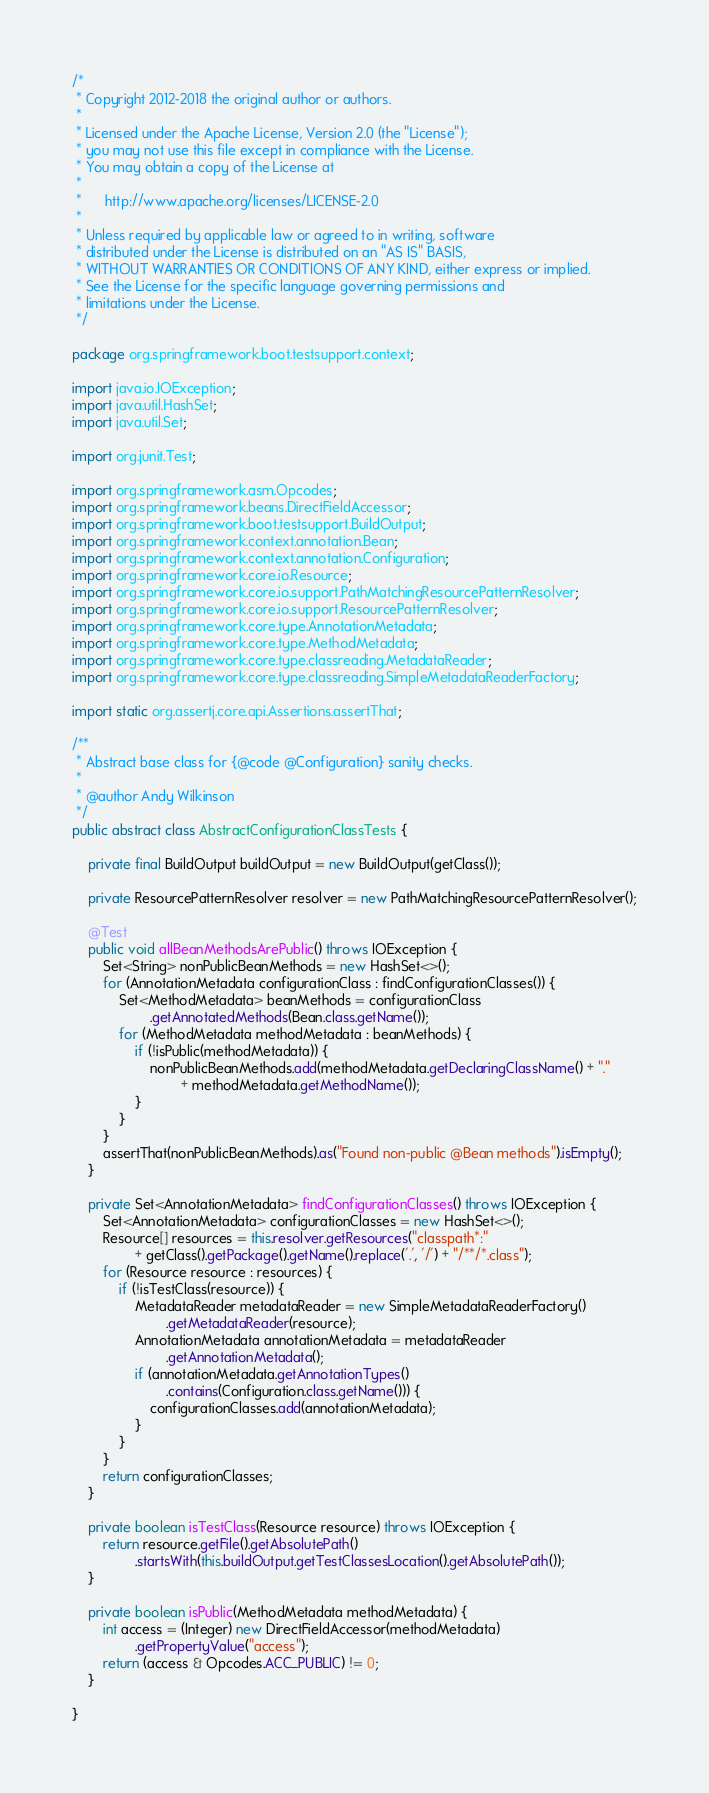Convert code to text. <code><loc_0><loc_0><loc_500><loc_500><_Java_>/*
 * Copyright 2012-2018 the original author or authors.
 *
 * Licensed under the Apache License, Version 2.0 (the "License");
 * you may not use this file except in compliance with the License.
 * You may obtain a copy of the License at
 *
 *      http://www.apache.org/licenses/LICENSE-2.0
 *
 * Unless required by applicable law or agreed to in writing, software
 * distributed under the License is distributed on an "AS IS" BASIS,
 * WITHOUT WARRANTIES OR CONDITIONS OF ANY KIND, either express or implied.
 * See the License for the specific language governing permissions and
 * limitations under the License.
 */

package org.springframework.boot.testsupport.context;

import java.io.IOException;
import java.util.HashSet;
import java.util.Set;

import org.junit.Test;

import org.springframework.asm.Opcodes;
import org.springframework.beans.DirectFieldAccessor;
import org.springframework.boot.testsupport.BuildOutput;
import org.springframework.context.annotation.Bean;
import org.springframework.context.annotation.Configuration;
import org.springframework.core.io.Resource;
import org.springframework.core.io.support.PathMatchingResourcePatternResolver;
import org.springframework.core.io.support.ResourcePatternResolver;
import org.springframework.core.type.AnnotationMetadata;
import org.springframework.core.type.MethodMetadata;
import org.springframework.core.type.classreading.MetadataReader;
import org.springframework.core.type.classreading.SimpleMetadataReaderFactory;

import static org.assertj.core.api.Assertions.assertThat;

/**
 * Abstract base class for {@code @Configuration} sanity checks.
 *
 * @author Andy Wilkinson
 */
public abstract class AbstractConfigurationClassTests {

	private final BuildOutput buildOutput = new BuildOutput(getClass());

	private ResourcePatternResolver resolver = new PathMatchingResourcePatternResolver();

	@Test
	public void allBeanMethodsArePublic() throws IOException {
		Set<String> nonPublicBeanMethods = new HashSet<>();
		for (AnnotationMetadata configurationClass : findConfigurationClasses()) {
			Set<MethodMetadata> beanMethods = configurationClass
					.getAnnotatedMethods(Bean.class.getName());
			for (MethodMetadata methodMetadata : beanMethods) {
				if (!isPublic(methodMetadata)) {
					nonPublicBeanMethods.add(methodMetadata.getDeclaringClassName() + "."
							+ methodMetadata.getMethodName());
				}
			}
		}
		assertThat(nonPublicBeanMethods).as("Found non-public @Bean methods").isEmpty();
	}

	private Set<AnnotationMetadata> findConfigurationClasses() throws IOException {
		Set<AnnotationMetadata> configurationClasses = new HashSet<>();
		Resource[] resources = this.resolver.getResources("classpath*:"
				+ getClass().getPackage().getName().replace('.', '/') + "/**/*.class");
		for (Resource resource : resources) {
			if (!isTestClass(resource)) {
				MetadataReader metadataReader = new SimpleMetadataReaderFactory()
						.getMetadataReader(resource);
				AnnotationMetadata annotationMetadata = metadataReader
						.getAnnotationMetadata();
				if (annotationMetadata.getAnnotationTypes()
						.contains(Configuration.class.getName())) {
					configurationClasses.add(annotationMetadata);
				}
			}
		}
		return configurationClasses;
	}

	private boolean isTestClass(Resource resource) throws IOException {
		return resource.getFile().getAbsolutePath()
				.startsWith(this.buildOutput.getTestClassesLocation().getAbsolutePath());
	}

	private boolean isPublic(MethodMetadata methodMetadata) {
		int access = (Integer) new DirectFieldAccessor(methodMetadata)
				.getPropertyValue("access");
		return (access & Opcodes.ACC_PUBLIC) != 0;
	}

}
</code> 